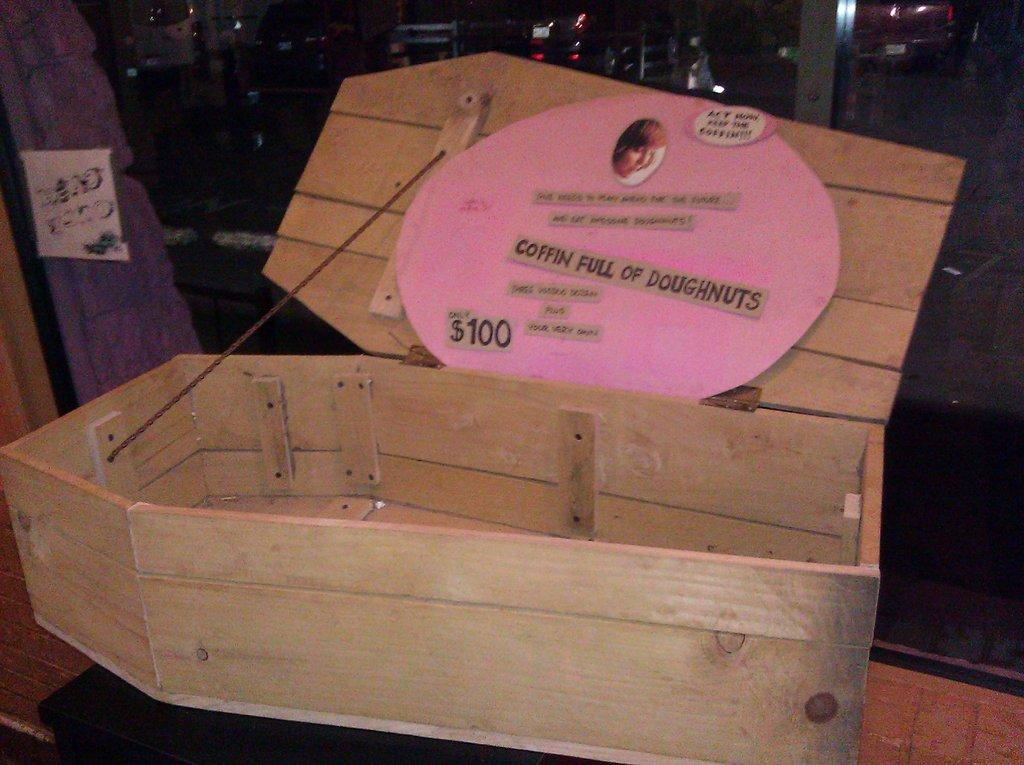Provide a one-sentence caption for the provided image. A wooden coffin is being used to sell doughnuts for $100. 